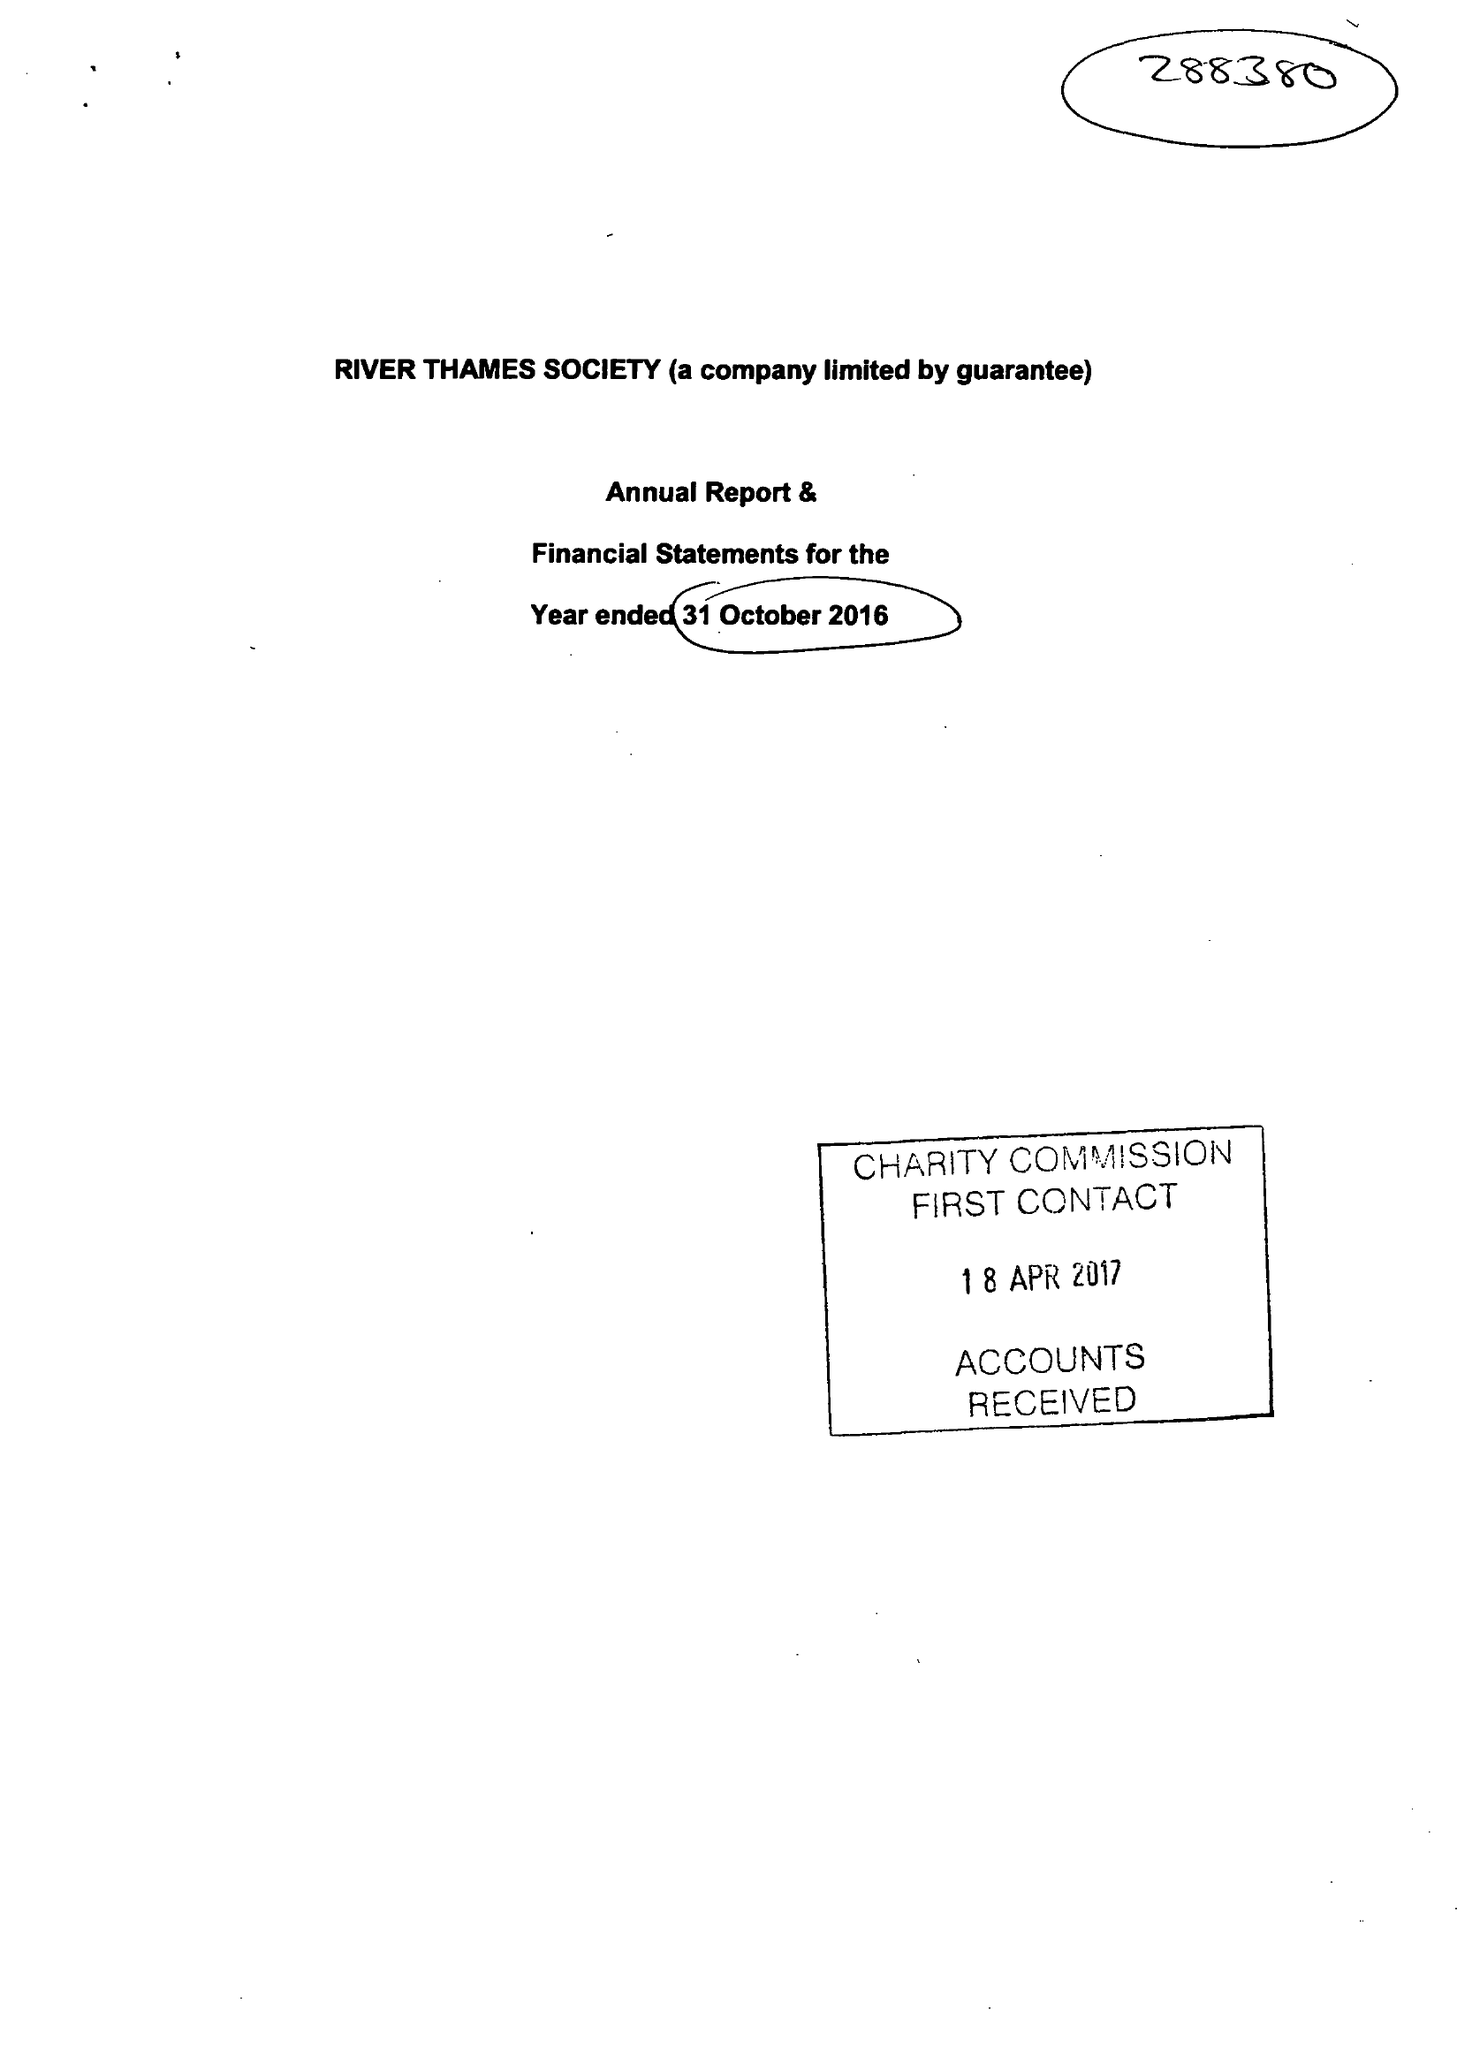What is the value for the report_date?
Answer the question using a single word or phrase. 2016-10-31 